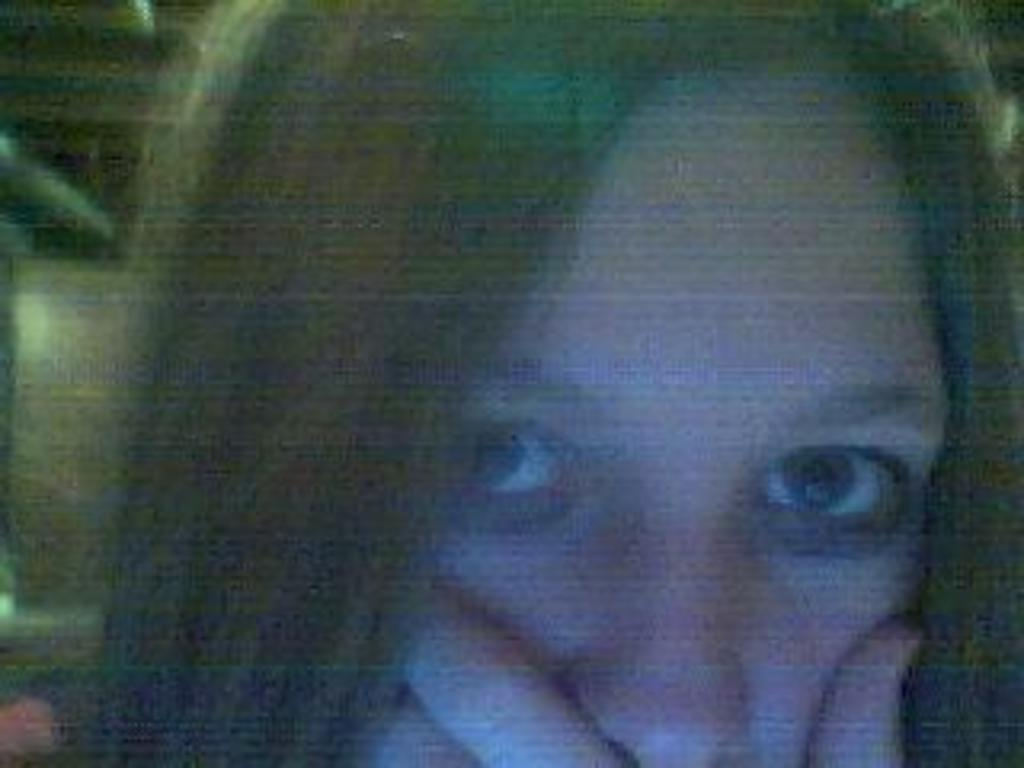Who is the main subject in the image? There is a girl in the image. Can you describe the background of the image? The background of the image is blurred. What type of discussion is taking place between the girl and the ball in the image? There is no ball present in the image, and therefore no discussion can be observed. 